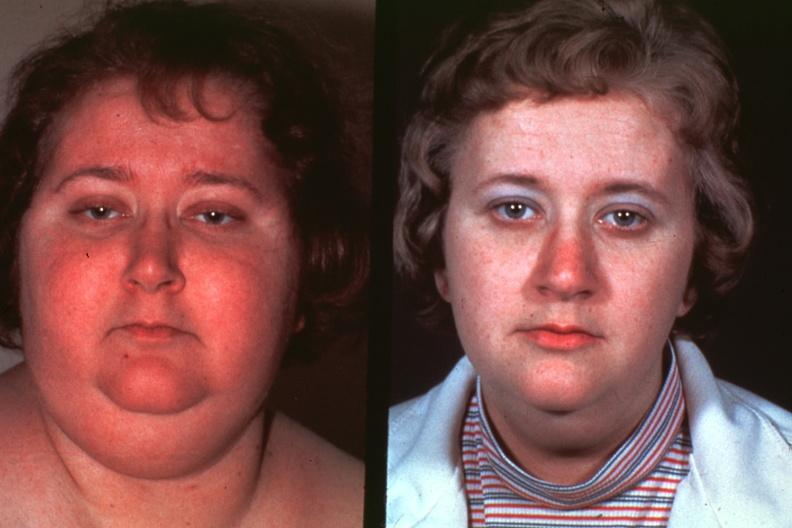s face present?
Answer the question using a single word or phrase. Yes 